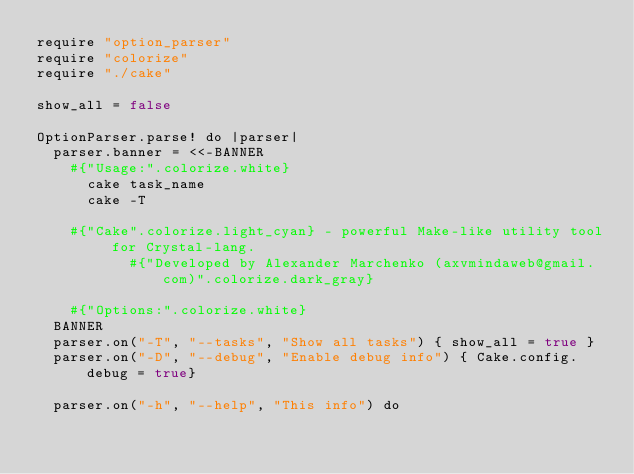Convert code to text. <code><loc_0><loc_0><loc_500><loc_500><_Crystal_>require "option_parser"
require "colorize"
require "./cake"

show_all = false

OptionParser.parse! do |parser|
  parser.banner = <<-BANNER
    #{"Usage:".colorize.white}
      cake task_name
      cake -T

    #{"Cake".colorize.light_cyan} - powerful Make-like utility tool for Crystal-lang.
           #{"Developed by Alexander Marchenko (axvmindaweb@gmail.com)".colorize.dark_gray}

    #{"Options:".colorize.white}
  BANNER
  parser.on("-T", "--tasks", "Show all tasks") { show_all = true }
  parser.on("-D", "--debug", "Enable debug info") { Cake.config.debug = true}

  parser.on("-h", "--help", "This info") do</code> 